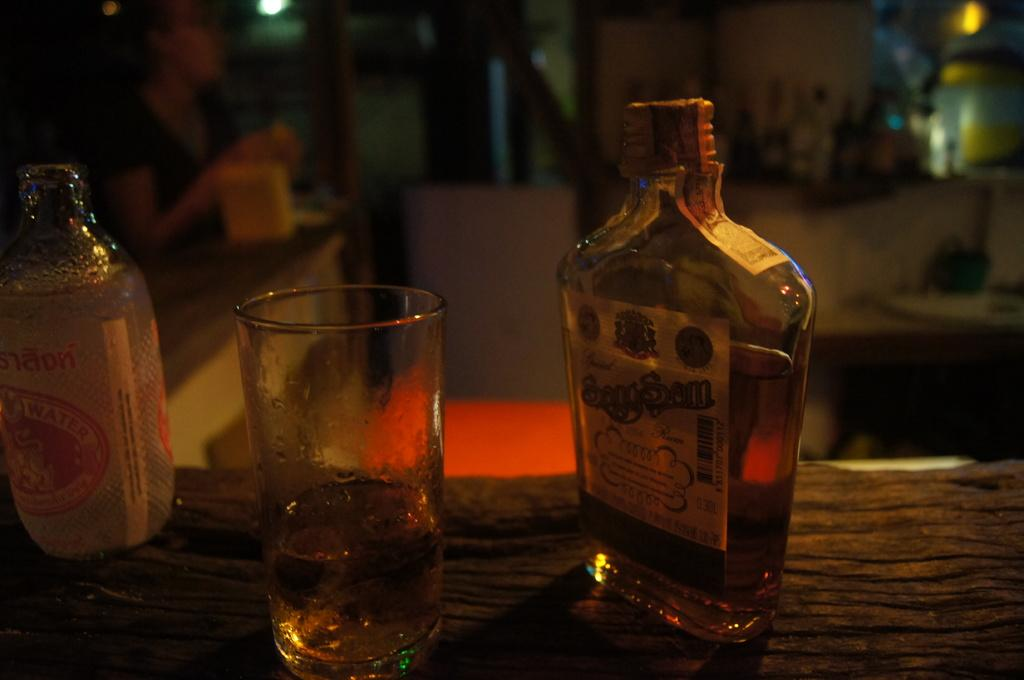Provide a one-sentence caption for the provided image. A bottle of rum sits next to an almost empty glass. 